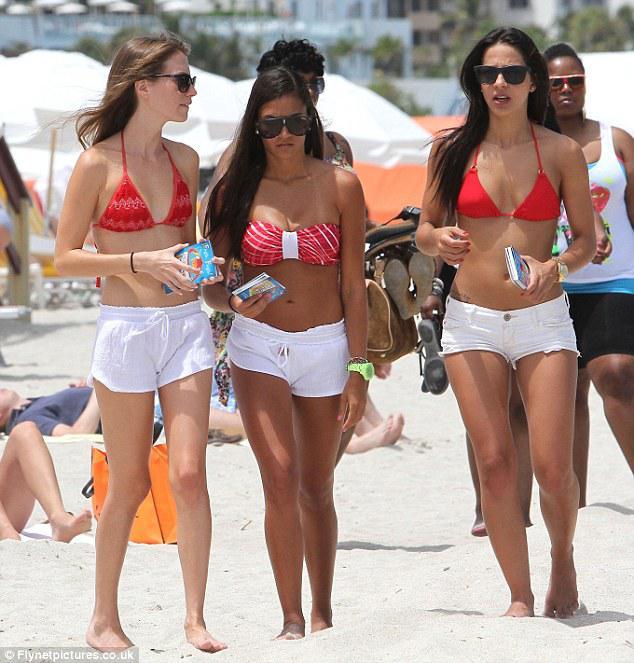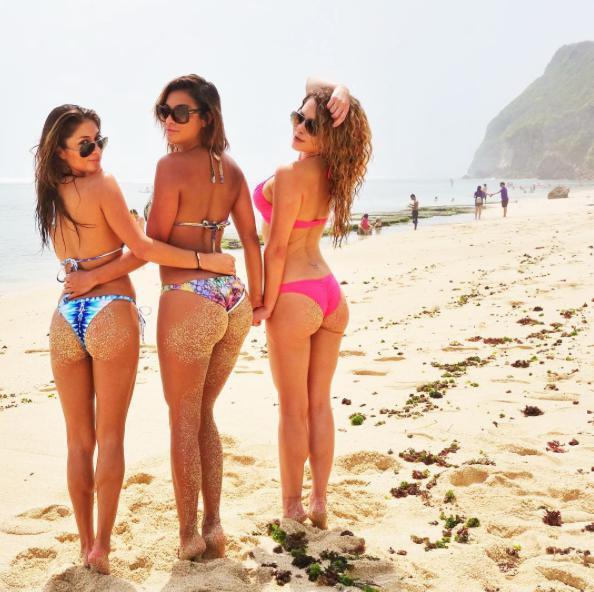The first image is the image on the left, the second image is the image on the right. Analyze the images presented: Is the assertion "One of the women is wearing a bright pink two piece bikini." valid? Answer yes or no. Yes. The first image is the image on the left, the second image is the image on the right. For the images shown, is this caption "Three girls stand side-by-side in bikini tops, and all wear the same color bottoms." true? Answer yes or no. Yes. 